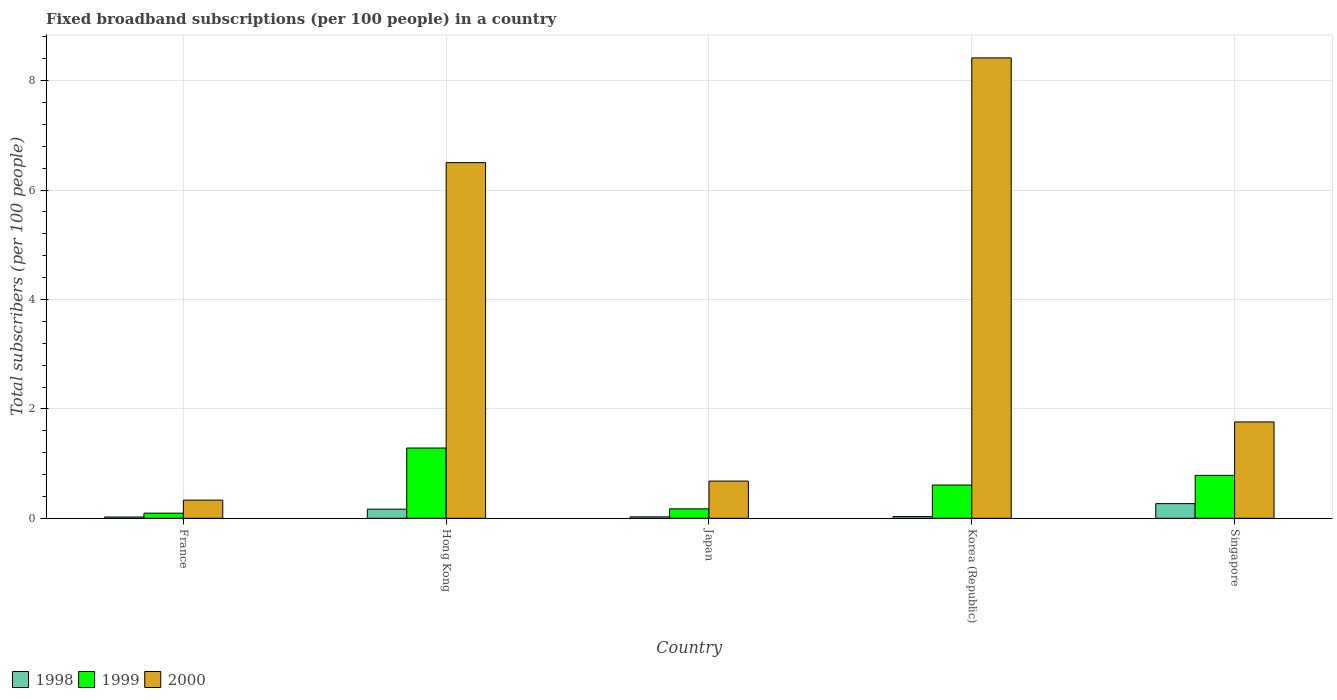How many groups of bars are there?
Keep it short and to the point. 5. Are the number of bars per tick equal to the number of legend labels?
Your answer should be compact. Yes. How many bars are there on the 2nd tick from the left?
Offer a terse response. 3. How many bars are there on the 2nd tick from the right?
Your answer should be very brief. 3. What is the label of the 1st group of bars from the left?
Give a very brief answer. France. In how many cases, is the number of bars for a given country not equal to the number of legend labels?
Ensure brevity in your answer.  0. What is the number of broadband subscriptions in 1998 in Japan?
Ensure brevity in your answer.  0.03. Across all countries, what is the maximum number of broadband subscriptions in 1999?
Provide a short and direct response. 1.28. Across all countries, what is the minimum number of broadband subscriptions in 1998?
Ensure brevity in your answer.  0.02. What is the total number of broadband subscriptions in 1999 in the graph?
Give a very brief answer. 2.94. What is the difference between the number of broadband subscriptions in 2000 in France and that in Hong Kong?
Ensure brevity in your answer.  -6.17. What is the difference between the number of broadband subscriptions in 1999 in Japan and the number of broadband subscriptions in 2000 in France?
Offer a very short reply. -0.16. What is the average number of broadband subscriptions in 1999 per country?
Offer a terse response. 0.59. What is the difference between the number of broadband subscriptions of/in 1998 and number of broadband subscriptions of/in 2000 in Singapore?
Provide a short and direct response. -1.49. What is the ratio of the number of broadband subscriptions in 1999 in Hong Kong to that in Singapore?
Offer a terse response. 1.64. Is the difference between the number of broadband subscriptions in 1998 in Hong Kong and Korea (Republic) greater than the difference between the number of broadband subscriptions in 2000 in Hong Kong and Korea (Republic)?
Offer a very short reply. Yes. What is the difference between the highest and the second highest number of broadband subscriptions in 1998?
Provide a succinct answer. 0.1. What is the difference between the highest and the lowest number of broadband subscriptions in 1999?
Provide a succinct answer. 1.19. In how many countries, is the number of broadband subscriptions in 1999 greater than the average number of broadband subscriptions in 1999 taken over all countries?
Your answer should be very brief. 3. How many bars are there?
Your answer should be compact. 15. How many countries are there in the graph?
Offer a terse response. 5. Are the values on the major ticks of Y-axis written in scientific E-notation?
Your response must be concise. No. Does the graph contain any zero values?
Your answer should be very brief. No. How are the legend labels stacked?
Your response must be concise. Horizontal. What is the title of the graph?
Provide a succinct answer. Fixed broadband subscriptions (per 100 people) in a country. What is the label or title of the Y-axis?
Offer a terse response. Total subscribers (per 100 people). What is the Total subscribers (per 100 people) of 1998 in France?
Provide a short and direct response. 0.02. What is the Total subscribers (per 100 people) of 1999 in France?
Your answer should be compact. 0.09. What is the Total subscribers (per 100 people) of 2000 in France?
Offer a terse response. 0.33. What is the Total subscribers (per 100 people) of 1998 in Hong Kong?
Your answer should be very brief. 0.17. What is the Total subscribers (per 100 people) in 1999 in Hong Kong?
Your answer should be compact. 1.28. What is the Total subscribers (per 100 people) in 2000 in Hong Kong?
Give a very brief answer. 6.5. What is the Total subscribers (per 100 people) of 1998 in Japan?
Ensure brevity in your answer.  0.03. What is the Total subscribers (per 100 people) of 1999 in Japan?
Keep it short and to the point. 0.17. What is the Total subscribers (per 100 people) in 2000 in Japan?
Your answer should be very brief. 0.68. What is the Total subscribers (per 100 people) in 1998 in Korea (Republic)?
Make the answer very short. 0.03. What is the Total subscribers (per 100 people) in 1999 in Korea (Republic)?
Your response must be concise. 0.61. What is the Total subscribers (per 100 people) of 2000 in Korea (Republic)?
Ensure brevity in your answer.  8.42. What is the Total subscribers (per 100 people) in 1998 in Singapore?
Offer a terse response. 0.27. What is the Total subscribers (per 100 people) of 1999 in Singapore?
Offer a terse response. 0.78. What is the Total subscribers (per 100 people) in 2000 in Singapore?
Provide a short and direct response. 1.76. Across all countries, what is the maximum Total subscribers (per 100 people) of 1998?
Provide a short and direct response. 0.27. Across all countries, what is the maximum Total subscribers (per 100 people) in 1999?
Your answer should be very brief. 1.28. Across all countries, what is the maximum Total subscribers (per 100 people) of 2000?
Make the answer very short. 8.42. Across all countries, what is the minimum Total subscribers (per 100 people) in 1998?
Make the answer very short. 0.02. Across all countries, what is the minimum Total subscribers (per 100 people) of 1999?
Your answer should be compact. 0.09. Across all countries, what is the minimum Total subscribers (per 100 people) of 2000?
Your answer should be very brief. 0.33. What is the total Total subscribers (per 100 people) in 1998 in the graph?
Ensure brevity in your answer.  0.51. What is the total Total subscribers (per 100 people) of 1999 in the graph?
Offer a very short reply. 2.94. What is the total Total subscribers (per 100 people) in 2000 in the graph?
Your answer should be very brief. 17.69. What is the difference between the Total subscribers (per 100 people) in 1998 in France and that in Hong Kong?
Your answer should be very brief. -0.14. What is the difference between the Total subscribers (per 100 people) of 1999 in France and that in Hong Kong?
Make the answer very short. -1.19. What is the difference between the Total subscribers (per 100 people) in 2000 in France and that in Hong Kong?
Ensure brevity in your answer.  -6.17. What is the difference between the Total subscribers (per 100 people) in 1998 in France and that in Japan?
Keep it short and to the point. -0. What is the difference between the Total subscribers (per 100 people) of 1999 in France and that in Japan?
Offer a very short reply. -0.08. What is the difference between the Total subscribers (per 100 people) of 2000 in France and that in Japan?
Offer a very short reply. -0.35. What is the difference between the Total subscribers (per 100 people) of 1998 in France and that in Korea (Republic)?
Give a very brief answer. -0.01. What is the difference between the Total subscribers (per 100 people) in 1999 in France and that in Korea (Republic)?
Your answer should be very brief. -0.51. What is the difference between the Total subscribers (per 100 people) of 2000 in France and that in Korea (Republic)?
Your response must be concise. -8.09. What is the difference between the Total subscribers (per 100 people) in 1998 in France and that in Singapore?
Offer a terse response. -0.24. What is the difference between the Total subscribers (per 100 people) in 1999 in France and that in Singapore?
Your answer should be compact. -0.69. What is the difference between the Total subscribers (per 100 people) of 2000 in France and that in Singapore?
Your response must be concise. -1.43. What is the difference between the Total subscribers (per 100 people) of 1998 in Hong Kong and that in Japan?
Your answer should be very brief. 0.14. What is the difference between the Total subscribers (per 100 people) of 1999 in Hong Kong and that in Japan?
Your response must be concise. 1.11. What is the difference between the Total subscribers (per 100 people) in 2000 in Hong Kong and that in Japan?
Give a very brief answer. 5.82. What is the difference between the Total subscribers (per 100 people) of 1998 in Hong Kong and that in Korea (Republic)?
Make the answer very short. 0.14. What is the difference between the Total subscribers (per 100 people) in 1999 in Hong Kong and that in Korea (Republic)?
Offer a terse response. 0.68. What is the difference between the Total subscribers (per 100 people) of 2000 in Hong Kong and that in Korea (Republic)?
Keep it short and to the point. -1.91. What is the difference between the Total subscribers (per 100 people) of 1998 in Hong Kong and that in Singapore?
Offer a very short reply. -0.1. What is the difference between the Total subscribers (per 100 people) in 1999 in Hong Kong and that in Singapore?
Give a very brief answer. 0.5. What is the difference between the Total subscribers (per 100 people) in 2000 in Hong Kong and that in Singapore?
Your response must be concise. 4.74. What is the difference between the Total subscribers (per 100 people) in 1998 in Japan and that in Korea (Republic)?
Your answer should be very brief. -0.01. What is the difference between the Total subscribers (per 100 people) of 1999 in Japan and that in Korea (Republic)?
Provide a short and direct response. -0.44. What is the difference between the Total subscribers (per 100 people) of 2000 in Japan and that in Korea (Republic)?
Offer a terse response. -7.74. What is the difference between the Total subscribers (per 100 people) of 1998 in Japan and that in Singapore?
Offer a terse response. -0.24. What is the difference between the Total subscribers (per 100 people) in 1999 in Japan and that in Singapore?
Offer a very short reply. -0.61. What is the difference between the Total subscribers (per 100 people) in 2000 in Japan and that in Singapore?
Ensure brevity in your answer.  -1.08. What is the difference between the Total subscribers (per 100 people) in 1998 in Korea (Republic) and that in Singapore?
Give a very brief answer. -0.24. What is the difference between the Total subscribers (per 100 people) in 1999 in Korea (Republic) and that in Singapore?
Your answer should be very brief. -0.18. What is the difference between the Total subscribers (per 100 people) of 2000 in Korea (Republic) and that in Singapore?
Your answer should be compact. 6.66. What is the difference between the Total subscribers (per 100 people) in 1998 in France and the Total subscribers (per 100 people) in 1999 in Hong Kong?
Your answer should be very brief. -1.26. What is the difference between the Total subscribers (per 100 people) in 1998 in France and the Total subscribers (per 100 people) in 2000 in Hong Kong?
Give a very brief answer. -6.48. What is the difference between the Total subscribers (per 100 people) in 1999 in France and the Total subscribers (per 100 people) in 2000 in Hong Kong?
Make the answer very short. -6.41. What is the difference between the Total subscribers (per 100 people) in 1998 in France and the Total subscribers (per 100 people) in 1999 in Japan?
Provide a short and direct response. -0.15. What is the difference between the Total subscribers (per 100 people) of 1998 in France and the Total subscribers (per 100 people) of 2000 in Japan?
Ensure brevity in your answer.  -0.66. What is the difference between the Total subscribers (per 100 people) of 1999 in France and the Total subscribers (per 100 people) of 2000 in Japan?
Your answer should be compact. -0.59. What is the difference between the Total subscribers (per 100 people) in 1998 in France and the Total subscribers (per 100 people) in 1999 in Korea (Republic)?
Provide a succinct answer. -0.58. What is the difference between the Total subscribers (per 100 people) of 1998 in France and the Total subscribers (per 100 people) of 2000 in Korea (Republic)?
Provide a succinct answer. -8.39. What is the difference between the Total subscribers (per 100 people) in 1999 in France and the Total subscribers (per 100 people) in 2000 in Korea (Republic)?
Your response must be concise. -8.32. What is the difference between the Total subscribers (per 100 people) in 1998 in France and the Total subscribers (per 100 people) in 1999 in Singapore?
Provide a succinct answer. -0.76. What is the difference between the Total subscribers (per 100 people) in 1998 in France and the Total subscribers (per 100 people) in 2000 in Singapore?
Your answer should be very brief. -1.74. What is the difference between the Total subscribers (per 100 people) in 1999 in France and the Total subscribers (per 100 people) in 2000 in Singapore?
Keep it short and to the point. -1.67. What is the difference between the Total subscribers (per 100 people) in 1998 in Hong Kong and the Total subscribers (per 100 people) in 1999 in Japan?
Your answer should be very brief. -0.01. What is the difference between the Total subscribers (per 100 people) of 1998 in Hong Kong and the Total subscribers (per 100 people) of 2000 in Japan?
Your answer should be very brief. -0.51. What is the difference between the Total subscribers (per 100 people) in 1999 in Hong Kong and the Total subscribers (per 100 people) in 2000 in Japan?
Your response must be concise. 0.6. What is the difference between the Total subscribers (per 100 people) in 1998 in Hong Kong and the Total subscribers (per 100 people) in 1999 in Korea (Republic)?
Give a very brief answer. -0.44. What is the difference between the Total subscribers (per 100 people) in 1998 in Hong Kong and the Total subscribers (per 100 people) in 2000 in Korea (Republic)?
Offer a very short reply. -8.25. What is the difference between the Total subscribers (per 100 people) of 1999 in Hong Kong and the Total subscribers (per 100 people) of 2000 in Korea (Republic)?
Ensure brevity in your answer.  -7.13. What is the difference between the Total subscribers (per 100 people) of 1998 in Hong Kong and the Total subscribers (per 100 people) of 1999 in Singapore?
Give a very brief answer. -0.62. What is the difference between the Total subscribers (per 100 people) of 1998 in Hong Kong and the Total subscribers (per 100 people) of 2000 in Singapore?
Your answer should be very brief. -1.59. What is the difference between the Total subscribers (per 100 people) in 1999 in Hong Kong and the Total subscribers (per 100 people) in 2000 in Singapore?
Offer a terse response. -0.48. What is the difference between the Total subscribers (per 100 people) of 1998 in Japan and the Total subscribers (per 100 people) of 1999 in Korea (Republic)?
Keep it short and to the point. -0.58. What is the difference between the Total subscribers (per 100 people) of 1998 in Japan and the Total subscribers (per 100 people) of 2000 in Korea (Republic)?
Your response must be concise. -8.39. What is the difference between the Total subscribers (per 100 people) of 1999 in Japan and the Total subscribers (per 100 people) of 2000 in Korea (Republic)?
Offer a terse response. -8.25. What is the difference between the Total subscribers (per 100 people) of 1998 in Japan and the Total subscribers (per 100 people) of 1999 in Singapore?
Offer a terse response. -0.76. What is the difference between the Total subscribers (per 100 people) in 1998 in Japan and the Total subscribers (per 100 people) in 2000 in Singapore?
Your answer should be compact. -1.74. What is the difference between the Total subscribers (per 100 people) in 1999 in Japan and the Total subscribers (per 100 people) in 2000 in Singapore?
Your answer should be compact. -1.59. What is the difference between the Total subscribers (per 100 people) of 1998 in Korea (Republic) and the Total subscribers (per 100 people) of 1999 in Singapore?
Offer a terse response. -0.75. What is the difference between the Total subscribers (per 100 people) of 1998 in Korea (Republic) and the Total subscribers (per 100 people) of 2000 in Singapore?
Offer a very short reply. -1.73. What is the difference between the Total subscribers (per 100 people) of 1999 in Korea (Republic) and the Total subscribers (per 100 people) of 2000 in Singapore?
Provide a succinct answer. -1.15. What is the average Total subscribers (per 100 people) in 1998 per country?
Your answer should be compact. 0.1. What is the average Total subscribers (per 100 people) of 1999 per country?
Offer a terse response. 0.59. What is the average Total subscribers (per 100 people) of 2000 per country?
Your answer should be very brief. 3.54. What is the difference between the Total subscribers (per 100 people) in 1998 and Total subscribers (per 100 people) in 1999 in France?
Your response must be concise. -0.07. What is the difference between the Total subscribers (per 100 people) of 1998 and Total subscribers (per 100 people) of 2000 in France?
Your answer should be compact. -0.31. What is the difference between the Total subscribers (per 100 people) of 1999 and Total subscribers (per 100 people) of 2000 in France?
Your response must be concise. -0.24. What is the difference between the Total subscribers (per 100 people) of 1998 and Total subscribers (per 100 people) of 1999 in Hong Kong?
Ensure brevity in your answer.  -1.12. What is the difference between the Total subscribers (per 100 people) of 1998 and Total subscribers (per 100 people) of 2000 in Hong Kong?
Keep it short and to the point. -6.34. What is the difference between the Total subscribers (per 100 people) of 1999 and Total subscribers (per 100 people) of 2000 in Hong Kong?
Keep it short and to the point. -5.22. What is the difference between the Total subscribers (per 100 people) of 1998 and Total subscribers (per 100 people) of 1999 in Japan?
Keep it short and to the point. -0.15. What is the difference between the Total subscribers (per 100 people) of 1998 and Total subscribers (per 100 people) of 2000 in Japan?
Provide a succinct answer. -0.65. What is the difference between the Total subscribers (per 100 people) of 1999 and Total subscribers (per 100 people) of 2000 in Japan?
Ensure brevity in your answer.  -0.51. What is the difference between the Total subscribers (per 100 people) of 1998 and Total subscribers (per 100 people) of 1999 in Korea (Republic)?
Your response must be concise. -0.58. What is the difference between the Total subscribers (per 100 people) in 1998 and Total subscribers (per 100 people) in 2000 in Korea (Republic)?
Provide a short and direct response. -8.39. What is the difference between the Total subscribers (per 100 people) of 1999 and Total subscribers (per 100 people) of 2000 in Korea (Republic)?
Keep it short and to the point. -7.81. What is the difference between the Total subscribers (per 100 people) in 1998 and Total subscribers (per 100 people) in 1999 in Singapore?
Your answer should be very brief. -0.52. What is the difference between the Total subscribers (per 100 people) of 1998 and Total subscribers (per 100 people) of 2000 in Singapore?
Ensure brevity in your answer.  -1.49. What is the difference between the Total subscribers (per 100 people) in 1999 and Total subscribers (per 100 people) in 2000 in Singapore?
Keep it short and to the point. -0.98. What is the ratio of the Total subscribers (per 100 people) in 1998 in France to that in Hong Kong?
Offer a very short reply. 0.14. What is the ratio of the Total subscribers (per 100 people) of 1999 in France to that in Hong Kong?
Keep it short and to the point. 0.07. What is the ratio of the Total subscribers (per 100 people) in 2000 in France to that in Hong Kong?
Provide a short and direct response. 0.05. What is the ratio of the Total subscribers (per 100 people) of 1998 in France to that in Japan?
Your answer should be very brief. 0.9. What is the ratio of the Total subscribers (per 100 people) in 1999 in France to that in Japan?
Give a very brief answer. 0.54. What is the ratio of the Total subscribers (per 100 people) of 2000 in France to that in Japan?
Your answer should be very brief. 0.49. What is the ratio of the Total subscribers (per 100 people) in 1998 in France to that in Korea (Republic)?
Your answer should be very brief. 0.75. What is the ratio of the Total subscribers (per 100 people) in 1999 in France to that in Korea (Republic)?
Provide a succinct answer. 0.15. What is the ratio of the Total subscribers (per 100 people) of 2000 in France to that in Korea (Republic)?
Offer a very short reply. 0.04. What is the ratio of the Total subscribers (per 100 people) in 1998 in France to that in Singapore?
Offer a terse response. 0.09. What is the ratio of the Total subscribers (per 100 people) of 1999 in France to that in Singapore?
Your answer should be compact. 0.12. What is the ratio of the Total subscribers (per 100 people) in 2000 in France to that in Singapore?
Your answer should be compact. 0.19. What is the ratio of the Total subscribers (per 100 people) in 1998 in Hong Kong to that in Japan?
Offer a terse response. 6.53. What is the ratio of the Total subscribers (per 100 people) of 1999 in Hong Kong to that in Japan?
Your answer should be very brief. 7.46. What is the ratio of the Total subscribers (per 100 people) in 2000 in Hong Kong to that in Japan?
Your answer should be compact. 9.56. What is the ratio of the Total subscribers (per 100 people) in 1998 in Hong Kong to that in Korea (Republic)?
Your answer should be very brief. 5.42. What is the ratio of the Total subscribers (per 100 people) of 1999 in Hong Kong to that in Korea (Republic)?
Provide a short and direct response. 2.11. What is the ratio of the Total subscribers (per 100 people) of 2000 in Hong Kong to that in Korea (Republic)?
Your answer should be compact. 0.77. What is the ratio of the Total subscribers (per 100 people) in 1998 in Hong Kong to that in Singapore?
Provide a succinct answer. 0.62. What is the ratio of the Total subscribers (per 100 people) in 1999 in Hong Kong to that in Singapore?
Your response must be concise. 1.64. What is the ratio of the Total subscribers (per 100 people) in 2000 in Hong Kong to that in Singapore?
Your answer should be very brief. 3.69. What is the ratio of the Total subscribers (per 100 people) of 1998 in Japan to that in Korea (Republic)?
Keep it short and to the point. 0.83. What is the ratio of the Total subscribers (per 100 people) of 1999 in Japan to that in Korea (Republic)?
Keep it short and to the point. 0.28. What is the ratio of the Total subscribers (per 100 people) in 2000 in Japan to that in Korea (Republic)?
Keep it short and to the point. 0.08. What is the ratio of the Total subscribers (per 100 people) of 1998 in Japan to that in Singapore?
Provide a succinct answer. 0.1. What is the ratio of the Total subscribers (per 100 people) of 1999 in Japan to that in Singapore?
Your answer should be compact. 0.22. What is the ratio of the Total subscribers (per 100 people) of 2000 in Japan to that in Singapore?
Ensure brevity in your answer.  0.39. What is the ratio of the Total subscribers (per 100 people) of 1998 in Korea (Republic) to that in Singapore?
Give a very brief answer. 0.12. What is the ratio of the Total subscribers (per 100 people) of 1999 in Korea (Republic) to that in Singapore?
Offer a very short reply. 0.77. What is the ratio of the Total subscribers (per 100 people) of 2000 in Korea (Republic) to that in Singapore?
Keep it short and to the point. 4.78. What is the difference between the highest and the second highest Total subscribers (per 100 people) of 1998?
Provide a short and direct response. 0.1. What is the difference between the highest and the second highest Total subscribers (per 100 people) of 1999?
Make the answer very short. 0.5. What is the difference between the highest and the second highest Total subscribers (per 100 people) of 2000?
Your answer should be compact. 1.91. What is the difference between the highest and the lowest Total subscribers (per 100 people) of 1998?
Offer a terse response. 0.24. What is the difference between the highest and the lowest Total subscribers (per 100 people) of 1999?
Keep it short and to the point. 1.19. What is the difference between the highest and the lowest Total subscribers (per 100 people) of 2000?
Provide a succinct answer. 8.09. 